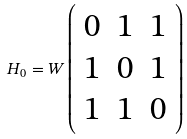<formula> <loc_0><loc_0><loc_500><loc_500>H _ { 0 } = W \left ( \begin{array} { c c c } 0 & 1 & 1 \\ 1 & 0 & 1 \\ 1 & 1 & 0 \end{array} \right )</formula> 